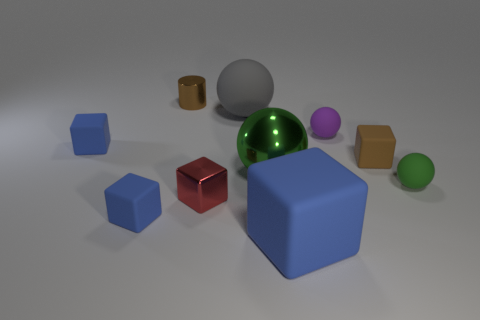What material is the thing that is the same color as the cylinder?
Keep it short and to the point. Rubber. There is a metallic ball; is it the same color as the small ball that is in front of the tiny purple sphere?
Your answer should be compact. Yes. Is there another cube of the same color as the big cube?
Provide a short and direct response. Yes. There is a tiny object that is the same color as the small metal cylinder; what is its shape?
Give a very brief answer. Cube. Is the size of the gray matte object the same as the metallic ball?
Make the answer very short. Yes. There is a large ball that is in front of the large matte thing behind the tiny metal cube; what is its material?
Offer a very short reply. Metal. There is a large rubber object behind the purple thing; is its shape the same as the green thing that is on the right side of the purple sphere?
Your response must be concise. Yes. Is the number of gray things in front of the green matte object the same as the number of big cyan rubber blocks?
Make the answer very short. Yes. Are there any matte things on the left side of the small brown object in front of the brown metal cylinder?
Offer a very short reply. Yes. Is there anything else of the same color as the big rubber cube?
Offer a very short reply. Yes. 